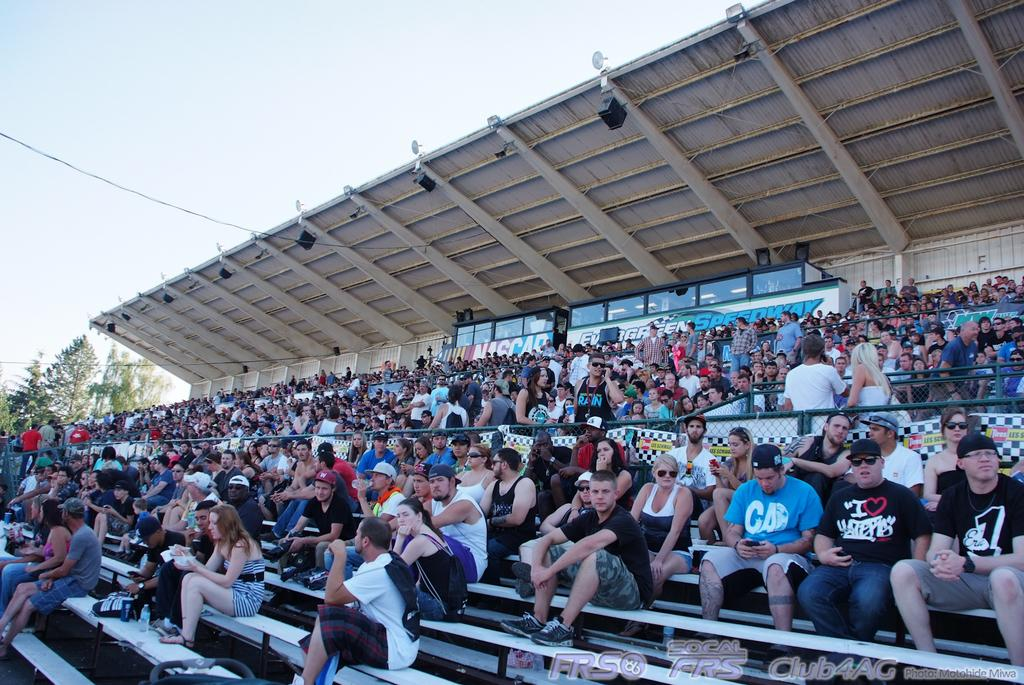What are the people in the image doing? There are many persons sitting on the stairs in the image. What can be seen in the background of the image? In the background of the image, there are lights, stands, iron rods, trees, and the sky. What type of corn is being harvested in the image? There is no corn present in the image; it features people sitting on stairs with various background elements. 